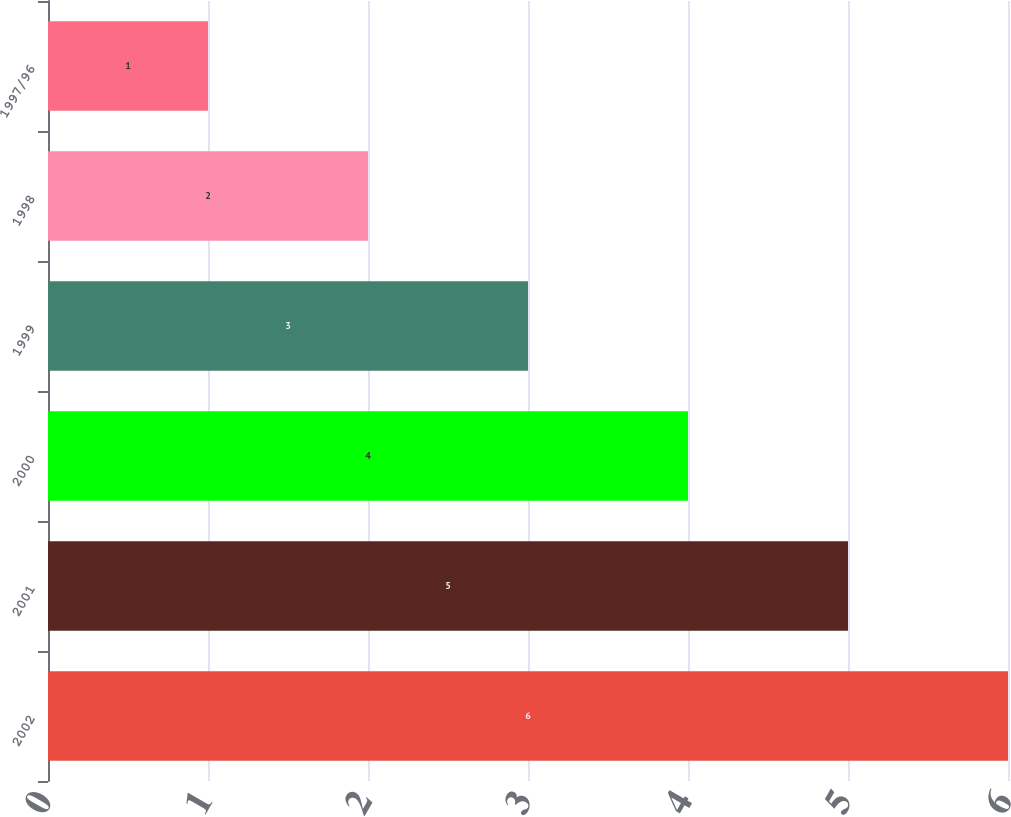Convert chart to OTSL. <chart><loc_0><loc_0><loc_500><loc_500><bar_chart><fcel>2002<fcel>2001<fcel>2000<fcel>1999<fcel>1998<fcel>1997/96<nl><fcel>6<fcel>5<fcel>4<fcel>3<fcel>2<fcel>1<nl></chart> 